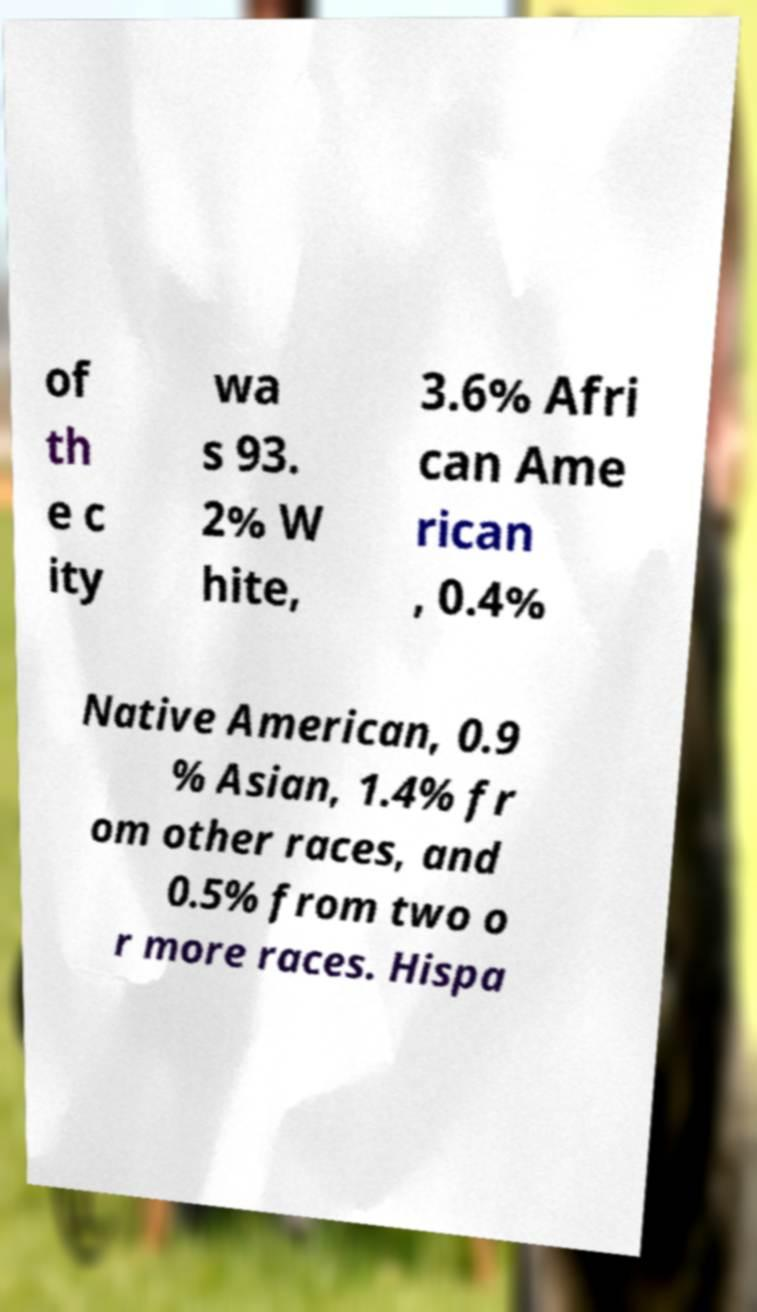Could you extract and type out the text from this image? of th e c ity wa s 93. 2% W hite, 3.6% Afri can Ame rican , 0.4% Native American, 0.9 % Asian, 1.4% fr om other races, and 0.5% from two o r more races. Hispa 